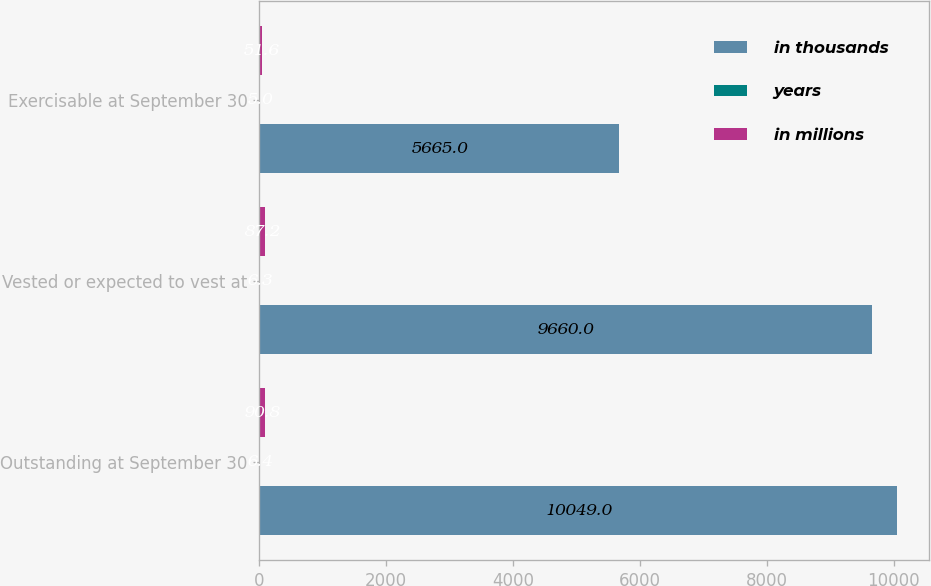Convert chart. <chart><loc_0><loc_0><loc_500><loc_500><stacked_bar_chart><ecel><fcel>Outstanding at September 30<fcel>Vested or expected to vest at<fcel>Exercisable at September 30<nl><fcel>in thousands<fcel>10049<fcel>9660<fcel>5665<nl><fcel>years<fcel>6.4<fcel>6.3<fcel>5<nl><fcel>in millions<fcel>90.8<fcel>87.2<fcel>51.6<nl></chart> 